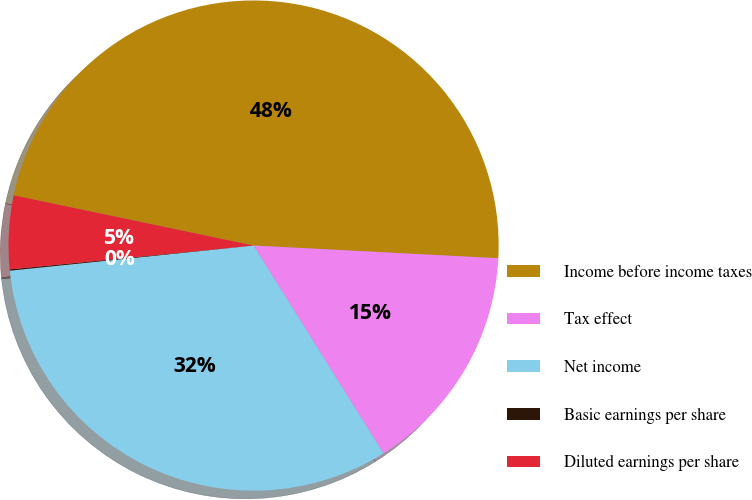Convert chart. <chart><loc_0><loc_0><loc_500><loc_500><pie_chart><fcel>Income before income taxes<fcel>Tax effect<fcel>Net income<fcel>Basic earnings per share<fcel>Diluted earnings per share<nl><fcel>47.54%<fcel>15.28%<fcel>32.26%<fcel>0.08%<fcel>4.84%<nl></chart> 